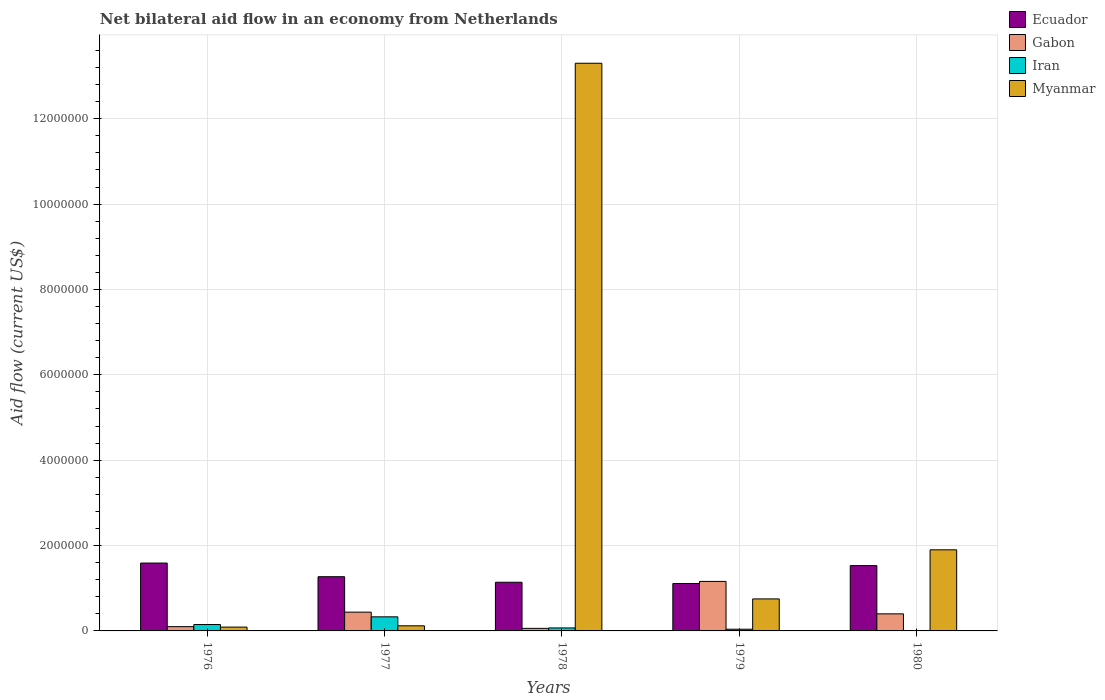How many groups of bars are there?
Make the answer very short. 5. Are the number of bars per tick equal to the number of legend labels?
Provide a succinct answer. Yes. Are the number of bars on each tick of the X-axis equal?
Your answer should be compact. Yes. What is the label of the 3rd group of bars from the left?
Give a very brief answer. 1978. In how many cases, is the number of bars for a given year not equal to the number of legend labels?
Ensure brevity in your answer.  0. What is the net bilateral aid flow in Myanmar in 1979?
Provide a short and direct response. 7.50e+05. Across all years, what is the maximum net bilateral aid flow in Iran?
Offer a terse response. 3.30e+05. In which year was the net bilateral aid flow in Myanmar maximum?
Your answer should be compact. 1978. In which year was the net bilateral aid flow in Gabon minimum?
Make the answer very short. 1978. What is the total net bilateral aid flow in Gabon in the graph?
Keep it short and to the point. 2.16e+06. What is the difference between the net bilateral aid flow in Gabon in 1977 and the net bilateral aid flow in Iran in 1978?
Keep it short and to the point. 3.70e+05. What is the average net bilateral aid flow in Gabon per year?
Provide a succinct answer. 4.32e+05. In the year 1979, what is the difference between the net bilateral aid flow in Iran and net bilateral aid flow in Myanmar?
Your answer should be compact. -7.10e+05. What is the ratio of the net bilateral aid flow in Gabon in 1977 to that in 1979?
Give a very brief answer. 0.38. Is the net bilateral aid flow in Gabon in 1976 less than that in 1980?
Offer a terse response. Yes. Is the difference between the net bilateral aid flow in Iran in 1976 and 1977 greater than the difference between the net bilateral aid flow in Myanmar in 1976 and 1977?
Offer a very short reply. No. What is the difference between the highest and the second highest net bilateral aid flow in Gabon?
Your response must be concise. 7.20e+05. What is the difference between the highest and the lowest net bilateral aid flow in Myanmar?
Offer a very short reply. 1.32e+07. Is the sum of the net bilateral aid flow in Myanmar in 1978 and 1979 greater than the maximum net bilateral aid flow in Ecuador across all years?
Your answer should be very brief. Yes. Is it the case that in every year, the sum of the net bilateral aid flow in Gabon and net bilateral aid flow in Iran is greater than the sum of net bilateral aid flow in Ecuador and net bilateral aid flow in Myanmar?
Offer a very short reply. No. What does the 2nd bar from the left in 1979 represents?
Offer a terse response. Gabon. What does the 2nd bar from the right in 1979 represents?
Provide a short and direct response. Iran. Is it the case that in every year, the sum of the net bilateral aid flow in Ecuador and net bilateral aid flow in Gabon is greater than the net bilateral aid flow in Iran?
Your answer should be compact. Yes. How many bars are there?
Provide a succinct answer. 20. How many years are there in the graph?
Provide a short and direct response. 5. Are the values on the major ticks of Y-axis written in scientific E-notation?
Your answer should be very brief. No. Where does the legend appear in the graph?
Offer a terse response. Top right. How many legend labels are there?
Ensure brevity in your answer.  4. What is the title of the graph?
Offer a very short reply. Net bilateral aid flow in an economy from Netherlands. Does "Gabon" appear as one of the legend labels in the graph?
Provide a short and direct response. Yes. What is the label or title of the Y-axis?
Your response must be concise. Aid flow (current US$). What is the Aid flow (current US$) of Ecuador in 1976?
Give a very brief answer. 1.59e+06. What is the Aid flow (current US$) in Gabon in 1976?
Your answer should be very brief. 1.00e+05. What is the Aid flow (current US$) of Iran in 1976?
Make the answer very short. 1.50e+05. What is the Aid flow (current US$) of Myanmar in 1976?
Your answer should be compact. 9.00e+04. What is the Aid flow (current US$) of Ecuador in 1977?
Keep it short and to the point. 1.27e+06. What is the Aid flow (current US$) in Gabon in 1977?
Your response must be concise. 4.40e+05. What is the Aid flow (current US$) in Iran in 1977?
Make the answer very short. 3.30e+05. What is the Aid flow (current US$) in Ecuador in 1978?
Provide a succinct answer. 1.14e+06. What is the Aid flow (current US$) of Iran in 1978?
Ensure brevity in your answer.  7.00e+04. What is the Aid flow (current US$) in Myanmar in 1978?
Ensure brevity in your answer.  1.33e+07. What is the Aid flow (current US$) in Ecuador in 1979?
Give a very brief answer. 1.11e+06. What is the Aid flow (current US$) in Gabon in 1979?
Give a very brief answer. 1.16e+06. What is the Aid flow (current US$) in Iran in 1979?
Offer a very short reply. 4.00e+04. What is the Aid flow (current US$) in Myanmar in 1979?
Your answer should be compact. 7.50e+05. What is the Aid flow (current US$) in Ecuador in 1980?
Keep it short and to the point. 1.53e+06. What is the Aid flow (current US$) in Gabon in 1980?
Give a very brief answer. 4.00e+05. What is the Aid flow (current US$) of Iran in 1980?
Your response must be concise. 10000. What is the Aid flow (current US$) of Myanmar in 1980?
Your answer should be compact. 1.90e+06. Across all years, what is the maximum Aid flow (current US$) of Ecuador?
Keep it short and to the point. 1.59e+06. Across all years, what is the maximum Aid flow (current US$) in Gabon?
Give a very brief answer. 1.16e+06. Across all years, what is the maximum Aid flow (current US$) in Iran?
Your response must be concise. 3.30e+05. Across all years, what is the maximum Aid flow (current US$) of Myanmar?
Your response must be concise. 1.33e+07. Across all years, what is the minimum Aid flow (current US$) in Ecuador?
Offer a terse response. 1.11e+06. Across all years, what is the minimum Aid flow (current US$) of Iran?
Give a very brief answer. 10000. Across all years, what is the minimum Aid flow (current US$) of Myanmar?
Your answer should be very brief. 9.00e+04. What is the total Aid flow (current US$) of Ecuador in the graph?
Give a very brief answer. 6.64e+06. What is the total Aid flow (current US$) in Gabon in the graph?
Your answer should be compact. 2.16e+06. What is the total Aid flow (current US$) in Myanmar in the graph?
Your response must be concise. 1.62e+07. What is the difference between the Aid flow (current US$) in Ecuador in 1976 and that in 1977?
Offer a terse response. 3.20e+05. What is the difference between the Aid flow (current US$) in Myanmar in 1976 and that in 1978?
Ensure brevity in your answer.  -1.32e+07. What is the difference between the Aid flow (current US$) in Gabon in 1976 and that in 1979?
Your answer should be very brief. -1.06e+06. What is the difference between the Aid flow (current US$) of Iran in 1976 and that in 1979?
Keep it short and to the point. 1.10e+05. What is the difference between the Aid flow (current US$) of Myanmar in 1976 and that in 1979?
Ensure brevity in your answer.  -6.60e+05. What is the difference between the Aid flow (current US$) of Ecuador in 1976 and that in 1980?
Keep it short and to the point. 6.00e+04. What is the difference between the Aid flow (current US$) in Gabon in 1976 and that in 1980?
Keep it short and to the point. -3.00e+05. What is the difference between the Aid flow (current US$) in Myanmar in 1976 and that in 1980?
Your answer should be compact. -1.81e+06. What is the difference between the Aid flow (current US$) in Myanmar in 1977 and that in 1978?
Ensure brevity in your answer.  -1.32e+07. What is the difference between the Aid flow (current US$) in Gabon in 1977 and that in 1979?
Provide a succinct answer. -7.20e+05. What is the difference between the Aid flow (current US$) of Iran in 1977 and that in 1979?
Your answer should be compact. 2.90e+05. What is the difference between the Aid flow (current US$) in Myanmar in 1977 and that in 1979?
Offer a very short reply. -6.30e+05. What is the difference between the Aid flow (current US$) in Ecuador in 1977 and that in 1980?
Ensure brevity in your answer.  -2.60e+05. What is the difference between the Aid flow (current US$) in Iran in 1977 and that in 1980?
Provide a succinct answer. 3.20e+05. What is the difference between the Aid flow (current US$) in Myanmar in 1977 and that in 1980?
Offer a terse response. -1.78e+06. What is the difference between the Aid flow (current US$) of Gabon in 1978 and that in 1979?
Your answer should be very brief. -1.10e+06. What is the difference between the Aid flow (current US$) of Iran in 1978 and that in 1979?
Your answer should be compact. 3.00e+04. What is the difference between the Aid flow (current US$) of Myanmar in 1978 and that in 1979?
Your response must be concise. 1.26e+07. What is the difference between the Aid flow (current US$) of Ecuador in 1978 and that in 1980?
Give a very brief answer. -3.90e+05. What is the difference between the Aid flow (current US$) of Gabon in 1978 and that in 1980?
Offer a terse response. -3.40e+05. What is the difference between the Aid flow (current US$) in Myanmar in 1978 and that in 1980?
Give a very brief answer. 1.14e+07. What is the difference between the Aid flow (current US$) in Ecuador in 1979 and that in 1980?
Provide a short and direct response. -4.20e+05. What is the difference between the Aid flow (current US$) of Gabon in 1979 and that in 1980?
Provide a succinct answer. 7.60e+05. What is the difference between the Aid flow (current US$) of Iran in 1979 and that in 1980?
Give a very brief answer. 3.00e+04. What is the difference between the Aid flow (current US$) in Myanmar in 1979 and that in 1980?
Keep it short and to the point. -1.15e+06. What is the difference between the Aid flow (current US$) in Ecuador in 1976 and the Aid flow (current US$) in Gabon in 1977?
Ensure brevity in your answer.  1.15e+06. What is the difference between the Aid flow (current US$) of Ecuador in 1976 and the Aid flow (current US$) of Iran in 1977?
Offer a very short reply. 1.26e+06. What is the difference between the Aid flow (current US$) in Ecuador in 1976 and the Aid flow (current US$) in Myanmar in 1977?
Provide a short and direct response. 1.47e+06. What is the difference between the Aid flow (current US$) of Iran in 1976 and the Aid flow (current US$) of Myanmar in 1977?
Your answer should be compact. 3.00e+04. What is the difference between the Aid flow (current US$) in Ecuador in 1976 and the Aid flow (current US$) in Gabon in 1978?
Your answer should be very brief. 1.53e+06. What is the difference between the Aid flow (current US$) in Ecuador in 1976 and the Aid flow (current US$) in Iran in 1978?
Offer a very short reply. 1.52e+06. What is the difference between the Aid flow (current US$) in Ecuador in 1976 and the Aid flow (current US$) in Myanmar in 1978?
Offer a very short reply. -1.17e+07. What is the difference between the Aid flow (current US$) of Gabon in 1976 and the Aid flow (current US$) of Myanmar in 1978?
Make the answer very short. -1.32e+07. What is the difference between the Aid flow (current US$) of Iran in 1976 and the Aid flow (current US$) of Myanmar in 1978?
Ensure brevity in your answer.  -1.32e+07. What is the difference between the Aid flow (current US$) of Ecuador in 1976 and the Aid flow (current US$) of Gabon in 1979?
Offer a very short reply. 4.30e+05. What is the difference between the Aid flow (current US$) of Ecuador in 1976 and the Aid flow (current US$) of Iran in 1979?
Make the answer very short. 1.55e+06. What is the difference between the Aid flow (current US$) in Ecuador in 1976 and the Aid flow (current US$) in Myanmar in 1979?
Offer a terse response. 8.40e+05. What is the difference between the Aid flow (current US$) in Gabon in 1976 and the Aid flow (current US$) in Myanmar in 1979?
Provide a succinct answer. -6.50e+05. What is the difference between the Aid flow (current US$) of Iran in 1976 and the Aid flow (current US$) of Myanmar in 1979?
Make the answer very short. -6.00e+05. What is the difference between the Aid flow (current US$) of Ecuador in 1976 and the Aid flow (current US$) of Gabon in 1980?
Provide a short and direct response. 1.19e+06. What is the difference between the Aid flow (current US$) of Ecuador in 1976 and the Aid flow (current US$) of Iran in 1980?
Ensure brevity in your answer.  1.58e+06. What is the difference between the Aid flow (current US$) in Ecuador in 1976 and the Aid flow (current US$) in Myanmar in 1980?
Ensure brevity in your answer.  -3.10e+05. What is the difference between the Aid flow (current US$) in Gabon in 1976 and the Aid flow (current US$) in Myanmar in 1980?
Make the answer very short. -1.80e+06. What is the difference between the Aid flow (current US$) in Iran in 1976 and the Aid flow (current US$) in Myanmar in 1980?
Your response must be concise. -1.75e+06. What is the difference between the Aid flow (current US$) of Ecuador in 1977 and the Aid flow (current US$) of Gabon in 1978?
Make the answer very short. 1.21e+06. What is the difference between the Aid flow (current US$) in Ecuador in 1977 and the Aid flow (current US$) in Iran in 1978?
Ensure brevity in your answer.  1.20e+06. What is the difference between the Aid flow (current US$) of Ecuador in 1977 and the Aid flow (current US$) of Myanmar in 1978?
Offer a very short reply. -1.20e+07. What is the difference between the Aid flow (current US$) in Gabon in 1977 and the Aid flow (current US$) in Iran in 1978?
Your answer should be very brief. 3.70e+05. What is the difference between the Aid flow (current US$) of Gabon in 1977 and the Aid flow (current US$) of Myanmar in 1978?
Make the answer very short. -1.29e+07. What is the difference between the Aid flow (current US$) of Iran in 1977 and the Aid flow (current US$) of Myanmar in 1978?
Give a very brief answer. -1.30e+07. What is the difference between the Aid flow (current US$) in Ecuador in 1977 and the Aid flow (current US$) in Iran in 1979?
Provide a succinct answer. 1.23e+06. What is the difference between the Aid flow (current US$) of Ecuador in 1977 and the Aid flow (current US$) of Myanmar in 1979?
Your answer should be very brief. 5.20e+05. What is the difference between the Aid flow (current US$) in Gabon in 1977 and the Aid flow (current US$) in Iran in 1979?
Your response must be concise. 4.00e+05. What is the difference between the Aid flow (current US$) of Gabon in 1977 and the Aid flow (current US$) of Myanmar in 1979?
Your answer should be compact. -3.10e+05. What is the difference between the Aid flow (current US$) in Iran in 1977 and the Aid flow (current US$) in Myanmar in 1979?
Your answer should be compact. -4.20e+05. What is the difference between the Aid flow (current US$) in Ecuador in 1977 and the Aid flow (current US$) in Gabon in 1980?
Give a very brief answer. 8.70e+05. What is the difference between the Aid flow (current US$) in Ecuador in 1977 and the Aid flow (current US$) in Iran in 1980?
Your answer should be very brief. 1.26e+06. What is the difference between the Aid flow (current US$) of Ecuador in 1977 and the Aid flow (current US$) of Myanmar in 1980?
Offer a terse response. -6.30e+05. What is the difference between the Aid flow (current US$) of Gabon in 1977 and the Aid flow (current US$) of Iran in 1980?
Give a very brief answer. 4.30e+05. What is the difference between the Aid flow (current US$) of Gabon in 1977 and the Aid flow (current US$) of Myanmar in 1980?
Make the answer very short. -1.46e+06. What is the difference between the Aid flow (current US$) of Iran in 1977 and the Aid flow (current US$) of Myanmar in 1980?
Your answer should be compact. -1.57e+06. What is the difference between the Aid flow (current US$) in Ecuador in 1978 and the Aid flow (current US$) in Iran in 1979?
Your response must be concise. 1.10e+06. What is the difference between the Aid flow (current US$) in Ecuador in 1978 and the Aid flow (current US$) in Myanmar in 1979?
Give a very brief answer. 3.90e+05. What is the difference between the Aid flow (current US$) in Gabon in 1978 and the Aid flow (current US$) in Iran in 1979?
Your answer should be compact. 2.00e+04. What is the difference between the Aid flow (current US$) in Gabon in 1978 and the Aid flow (current US$) in Myanmar in 1979?
Give a very brief answer. -6.90e+05. What is the difference between the Aid flow (current US$) of Iran in 1978 and the Aid flow (current US$) of Myanmar in 1979?
Ensure brevity in your answer.  -6.80e+05. What is the difference between the Aid flow (current US$) of Ecuador in 1978 and the Aid flow (current US$) of Gabon in 1980?
Keep it short and to the point. 7.40e+05. What is the difference between the Aid flow (current US$) in Ecuador in 1978 and the Aid flow (current US$) in Iran in 1980?
Provide a short and direct response. 1.13e+06. What is the difference between the Aid flow (current US$) of Ecuador in 1978 and the Aid flow (current US$) of Myanmar in 1980?
Make the answer very short. -7.60e+05. What is the difference between the Aid flow (current US$) in Gabon in 1978 and the Aid flow (current US$) in Myanmar in 1980?
Your answer should be compact. -1.84e+06. What is the difference between the Aid flow (current US$) in Iran in 1978 and the Aid flow (current US$) in Myanmar in 1980?
Provide a short and direct response. -1.83e+06. What is the difference between the Aid flow (current US$) of Ecuador in 1979 and the Aid flow (current US$) of Gabon in 1980?
Your answer should be compact. 7.10e+05. What is the difference between the Aid flow (current US$) of Ecuador in 1979 and the Aid flow (current US$) of Iran in 1980?
Your response must be concise. 1.10e+06. What is the difference between the Aid flow (current US$) of Ecuador in 1979 and the Aid flow (current US$) of Myanmar in 1980?
Provide a succinct answer. -7.90e+05. What is the difference between the Aid flow (current US$) of Gabon in 1979 and the Aid flow (current US$) of Iran in 1980?
Give a very brief answer. 1.15e+06. What is the difference between the Aid flow (current US$) of Gabon in 1979 and the Aid flow (current US$) of Myanmar in 1980?
Your response must be concise. -7.40e+05. What is the difference between the Aid flow (current US$) in Iran in 1979 and the Aid flow (current US$) in Myanmar in 1980?
Offer a terse response. -1.86e+06. What is the average Aid flow (current US$) of Ecuador per year?
Provide a succinct answer. 1.33e+06. What is the average Aid flow (current US$) in Gabon per year?
Your response must be concise. 4.32e+05. What is the average Aid flow (current US$) in Iran per year?
Ensure brevity in your answer.  1.20e+05. What is the average Aid flow (current US$) in Myanmar per year?
Offer a very short reply. 3.23e+06. In the year 1976, what is the difference between the Aid flow (current US$) in Ecuador and Aid flow (current US$) in Gabon?
Your response must be concise. 1.49e+06. In the year 1976, what is the difference between the Aid flow (current US$) of Ecuador and Aid flow (current US$) of Iran?
Keep it short and to the point. 1.44e+06. In the year 1976, what is the difference between the Aid flow (current US$) of Ecuador and Aid flow (current US$) of Myanmar?
Give a very brief answer. 1.50e+06. In the year 1976, what is the difference between the Aid flow (current US$) in Iran and Aid flow (current US$) in Myanmar?
Your answer should be very brief. 6.00e+04. In the year 1977, what is the difference between the Aid flow (current US$) of Ecuador and Aid flow (current US$) of Gabon?
Your response must be concise. 8.30e+05. In the year 1977, what is the difference between the Aid flow (current US$) of Ecuador and Aid flow (current US$) of Iran?
Keep it short and to the point. 9.40e+05. In the year 1977, what is the difference between the Aid flow (current US$) in Ecuador and Aid flow (current US$) in Myanmar?
Offer a terse response. 1.15e+06. In the year 1977, what is the difference between the Aid flow (current US$) in Iran and Aid flow (current US$) in Myanmar?
Your response must be concise. 2.10e+05. In the year 1978, what is the difference between the Aid flow (current US$) of Ecuador and Aid flow (current US$) of Gabon?
Your response must be concise. 1.08e+06. In the year 1978, what is the difference between the Aid flow (current US$) of Ecuador and Aid flow (current US$) of Iran?
Provide a succinct answer. 1.07e+06. In the year 1978, what is the difference between the Aid flow (current US$) of Ecuador and Aid flow (current US$) of Myanmar?
Your answer should be very brief. -1.22e+07. In the year 1978, what is the difference between the Aid flow (current US$) in Gabon and Aid flow (current US$) in Iran?
Your response must be concise. -10000. In the year 1978, what is the difference between the Aid flow (current US$) of Gabon and Aid flow (current US$) of Myanmar?
Ensure brevity in your answer.  -1.32e+07. In the year 1978, what is the difference between the Aid flow (current US$) of Iran and Aid flow (current US$) of Myanmar?
Your response must be concise. -1.32e+07. In the year 1979, what is the difference between the Aid flow (current US$) of Ecuador and Aid flow (current US$) of Gabon?
Your response must be concise. -5.00e+04. In the year 1979, what is the difference between the Aid flow (current US$) in Ecuador and Aid flow (current US$) in Iran?
Offer a very short reply. 1.07e+06. In the year 1979, what is the difference between the Aid flow (current US$) in Ecuador and Aid flow (current US$) in Myanmar?
Your response must be concise. 3.60e+05. In the year 1979, what is the difference between the Aid flow (current US$) of Gabon and Aid flow (current US$) of Iran?
Your response must be concise. 1.12e+06. In the year 1979, what is the difference between the Aid flow (current US$) of Iran and Aid flow (current US$) of Myanmar?
Offer a terse response. -7.10e+05. In the year 1980, what is the difference between the Aid flow (current US$) of Ecuador and Aid flow (current US$) of Gabon?
Provide a succinct answer. 1.13e+06. In the year 1980, what is the difference between the Aid flow (current US$) in Ecuador and Aid flow (current US$) in Iran?
Your answer should be compact. 1.52e+06. In the year 1980, what is the difference between the Aid flow (current US$) of Ecuador and Aid flow (current US$) of Myanmar?
Keep it short and to the point. -3.70e+05. In the year 1980, what is the difference between the Aid flow (current US$) of Gabon and Aid flow (current US$) of Iran?
Keep it short and to the point. 3.90e+05. In the year 1980, what is the difference between the Aid flow (current US$) of Gabon and Aid flow (current US$) of Myanmar?
Ensure brevity in your answer.  -1.50e+06. In the year 1980, what is the difference between the Aid flow (current US$) in Iran and Aid flow (current US$) in Myanmar?
Offer a very short reply. -1.89e+06. What is the ratio of the Aid flow (current US$) in Ecuador in 1976 to that in 1977?
Offer a very short reply. 1.25. What is the ratio of the Aid flow (current US$) in Gabon in 1976 to that in 1977?
Provide a short and direct response. 0.23. What is the ratio of the Aid flow (current US$) in Iran in 1976 to that in 1977?
Offer a terse response. 0.45. What is the ratio of the Aid flow (current US$) in Ecuador in 1976 to that in 1978?
Your answer should be very brief. 1.39. What is the ratio of the Aid flow (current US$) of Gabon in 1976 to that in 1978?
Your response must be concise. 1.67. What is the ratio of the Aid flow (current US$) of Iran in 1976 to that in 1978?
Give a very brief answer. 2.14. What is the ratio of the Aid flow (current US$) of Myanmar in 1976 to that in 1978?
Your answer should be very brief. 0.01. What is the ratio of the Aid flow (current US$) in Ecuador in 1976 to that in 1979?
Make the answer very short. 1.43. What is the ratio of the Aid flow (current US$) of Gabon in 1976 to that in 1979?
Your answer should be very brief. 0.09. What is the ratio of the Aid flow (current US$) in Iran in 1976 to that in 1979?
Offer a very short reply. 3.75. What is the ratio of the Aid flow (current US$) in Myanmar in 1976 to that in 1979?
Provide a succinct answer. 0.12. What is the ratio of the Aid flow (current US$) of Ecuador in 1976 to that in 1980?
Your answer should be compact. 1.04. What is the ratio of the Aid flow (current US$) of Iran in 1976 to that in 1980?
Your answer should be very brief. 15. What is the ratio of the Aid flow (current US$) of Myanmar in 1976 to that in 1980?
Ensure brevity in your answer.  0.05. What is the ratio of the Aid flow (current US$) in Ecuador in 1977 to that in 1978?
Give a very brief answer. 1.11. What is the ratio of the Aid flow (current US$) of Gabon in 1977 to that in 1978?
Your answer should be very brief. 7.33. What is the ratio of the Aid flow (current US$) of Iran in 1977 to that in 1978?
Make the answer very short. 4.71. What is the ratio of the Aid flow (current US$) in Myanmar in 1977 to that in 1978?
Provide a short and direct response. 0.01. What is the ratio of the Aid flow (current US$) of Ecuador in 1977 to that in 1979?
Make the answer very short. 1.14. What is the ratio of the Aid flow (current US$) of Gabon in 1977 to that in 1979?
Keep it short and to the point. 0.38. What is the ratio of the Aid flow (current US$) of Iran in 1977 to that in 1979?
Provide a short and direct response. 8.25. What is the ratio of the Aid flow (current US$) in Myanmar in 1977 to that in 1979?
Keep it short and to the point. 0.16. What is the ratio of the Aid flow (current US$) of Ecuador in 1977 to that in 1980?
Make the answer very short. 0.83. What is the ratio of the Aid flow (current US$) in Gabon in 1977 to that in 1980?
Provide a short and direct response. 1.1. What is the ratio of the Aid flow (current US$) in Myanmar in 1977 to that in 1980?
Keep it short and to the point. 0.06. What is the ratio of the Aid flow (current US$) in Ecuador in 1978 to that in 1979?
Provide a short and direct response. 1.03. What is the ratio of the Aid flow (current US$) of Gabon in 1978 to that in 1979?
Your response must be concise. 0.05. What is the ratio of the Aid flow (current US$) of Iran in 1978 to that in 1979?
Offer a very short reply. 1.75. What is the ratio of the Aid flow (current US$) of Myanmar in 1978 to that in 1979?
Provide a short and direct response. 17.73. What is the ratio of the Aid flow (current US$) in Ecuador in 1978 to that in 1980?
Make the answer very short. 0.75. What is the ratio of the Aid flow (current US$) in Gabon in 1978 to that in 1980?
Your answer should be very brief. 0.15. What is the ratio of the Aid flow (current US$) in Ecuador in 1979 to that in 1980?
Keep it short and to the point. 0.73. What is the ratio of the Aid flow (current US$) of Gabon in 1979 to that in 1980?
Keep it short and to the point. 2.9. What is the ratio of the Aid flow (current US$) in Myanmar in 1979 to that in 1980?
Make the answer very short. 0.39. What is the difference between the highest and the second highest Aid flow (current US$) of Ecuador?
Your answer should be compact. 6.00e+04. What is the difference between the highest and the second highest Aid flow (current US$) of Gabon?
Your answer should be compact. 7.20e+05. What is the difference between the highest and the second highest Aid flow (current US$) of Iran?
Offer a terse response. 1.80e+05. What is the difference between the highest and the second highest Aid flow (current US$) of Myanmar?
Make the answer very short. 1.14e+07. What is the difference between the highest and the lowest Aid flow (current US$) of Gabon?
Offer a very short reply. 1.10e+06. What is the difference between the highest and the lowest Aid flow (current US$) of Iran?
Keep it short and to the point. 3.20e+05. What is the difference between the highest and the lowest Aid flow (current US$) in Myanmar?
Your response must be concise. 1.32e+07. 